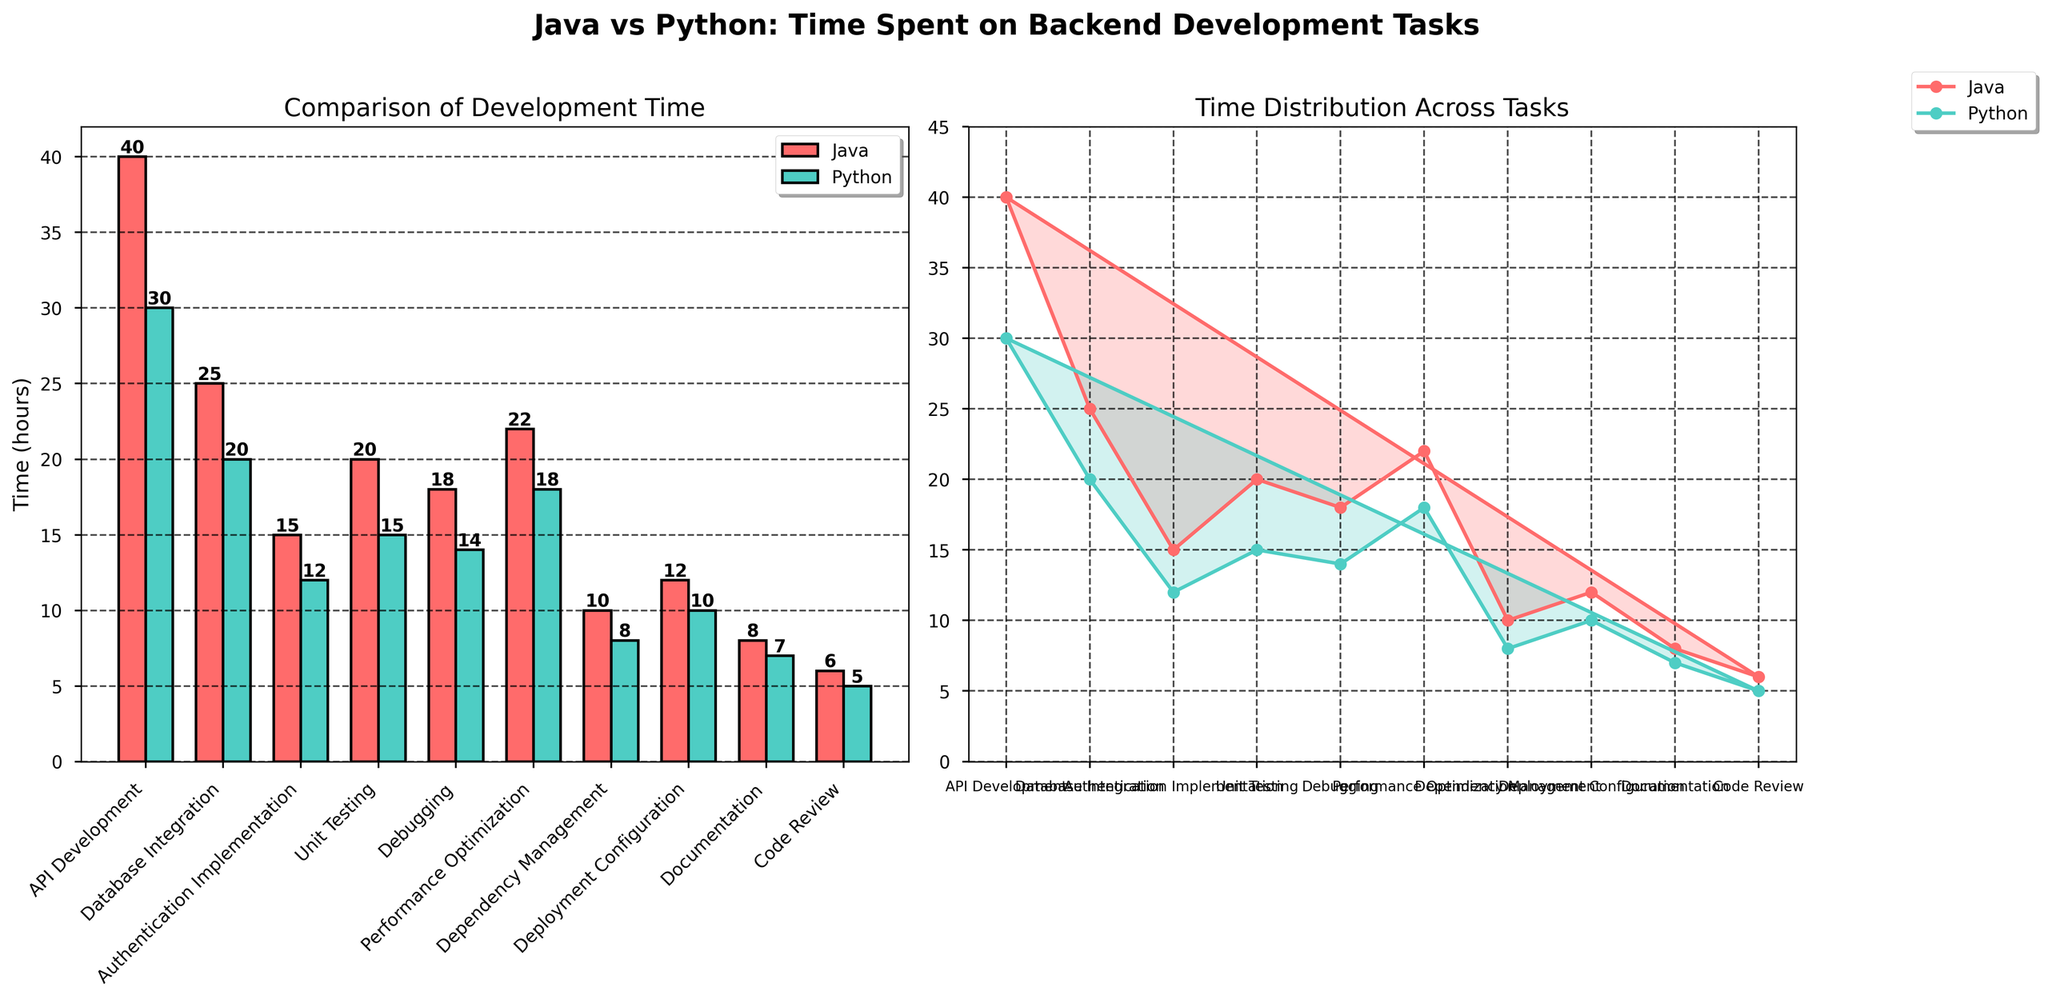What is the title of the figure? The title of the figure is displayed at the top in bold and large font. It summarizes the content of the figure.
Answer: Java vs Python: Time Spent on Backend Development Tasks Which task has the shortest development time for both Java and Python? We need to identify the shortest bar in both the Java and Python categories from the bar plot. The shortest bar corresponds to the "Code Review" task.
Answer: Code Review How much time is saved on API Development when using Python instead of Java? Subtract the time spent on API Development using Python from the time spent using Java: 40 - 30 = 10 hours.
Answer: 10 hours What are the tasks where Python took less time than Java? Compare each pair of bars in the bar plot. If the Python bar is shorter, note the task.
Answer: All tasks What is the average time spent on deployment configuration for Java and Python combined? Add the hours spent on deployment configuration for both Java and Python and divide by 2: (12 + 10) / 2 = 11 hours.
Answer: 11 hours How does the time spent on unit testing compare between Java and Python? Look at the bar heights for Unit Testing. Java took 20 hours, and Python took 15 hours. Java took more time than Python.
Answer: Java took 5 more hours In the radar plot, which task shows the largest difference in time between Java and Python? In the radar plot, the API Development segment has the largest gap between the plotted points for Java and Python.
Answer: API Development What is the total development time for both Java and Python across all tasks? Sum all the hours spent on each task for both Java and Python: Java total = 40 + 25 + 15 + 20 + 18 + 22 + 10 + 12 + 8 + 6 = 176 hours; Python total = 30 + 20 + 12 + 15 + 14 + 18 + 8 + 10 + 7 + 5 = 139 hours
Answer: 176 hours (Java), 139 hours (Python) What proportion of the total Java development time is spent on database integration? Divide the hours spent on database integration by the total Java development time and convert to a percentage: (25 / 176) * 100 ≈ 14.2%.
Answer: 14.2% Which task shows the smallest time difference between Java and Python? Look for the pair of bars or radar plot points with the smallest difference. The "Documentation" task shows the smallest difference: 1 hour.
Answer: Documentation 